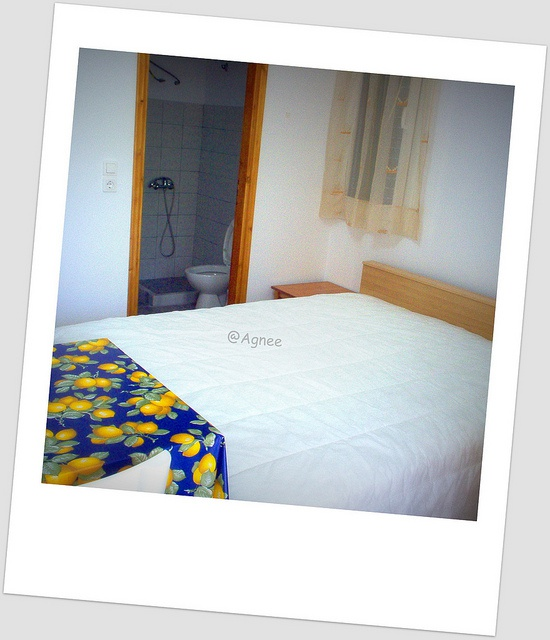Describe the objects in this image and their specific colors. I can see bed in lightgray, darkgray, lightblue, and navy tones and toilet in lightgray, gray, and navy tones in this image. 